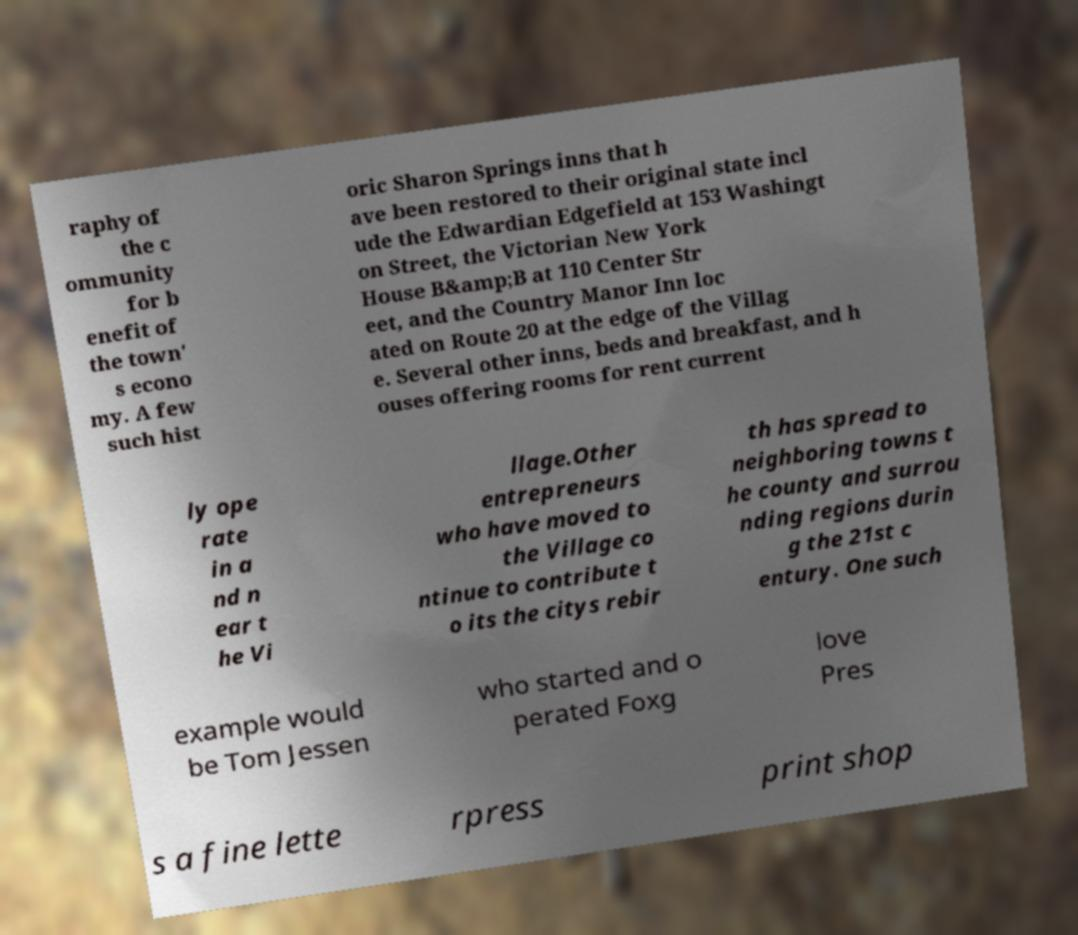Can you accurately transcribe the text from the provided image for me? raphy of the c ommunity for b enefit of the town' s econo my. A few such hist oric Sharon Springs inns that h ave been restored to their original state incl ude the Edwardian Edgefield at 153 Washingt on Street, the Victorian New York House B&amp;B at 110 Center Str eet, and the Country Manor Inn loc ated on Route 20 at the edge of the Villag e. Several other inns, beds and breakfast, and h ouses offering rooms for rent current ly ope rate in a nd n ear t he Vi llage.Other entrepreneurs who have moved to the Village co ntinue to contribute t o its the citys rebir th has spread to neighboring towns t he county and surrou nding regions durin g the 21st c entury. One such example would be Tom Jessen who started and o perated Foxg love Pres s a fine lette rpress print shop 